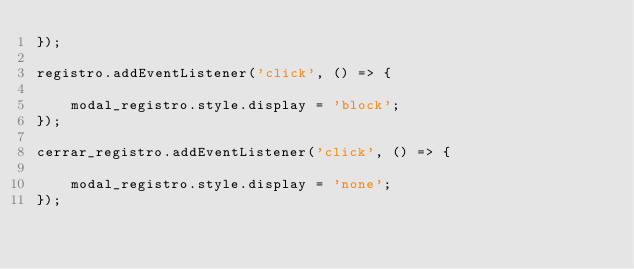Convert code to text. <code><loc_0><loc_0><loc_500><loc_500><_JavaScript_>});

registro.addEventListener('click', () => {

    modal_registro.style.display = 'block';
});

cerrar_registro.addEventListener('click', () => {

    modal_registro.style.display = 'none';
});


</code> 